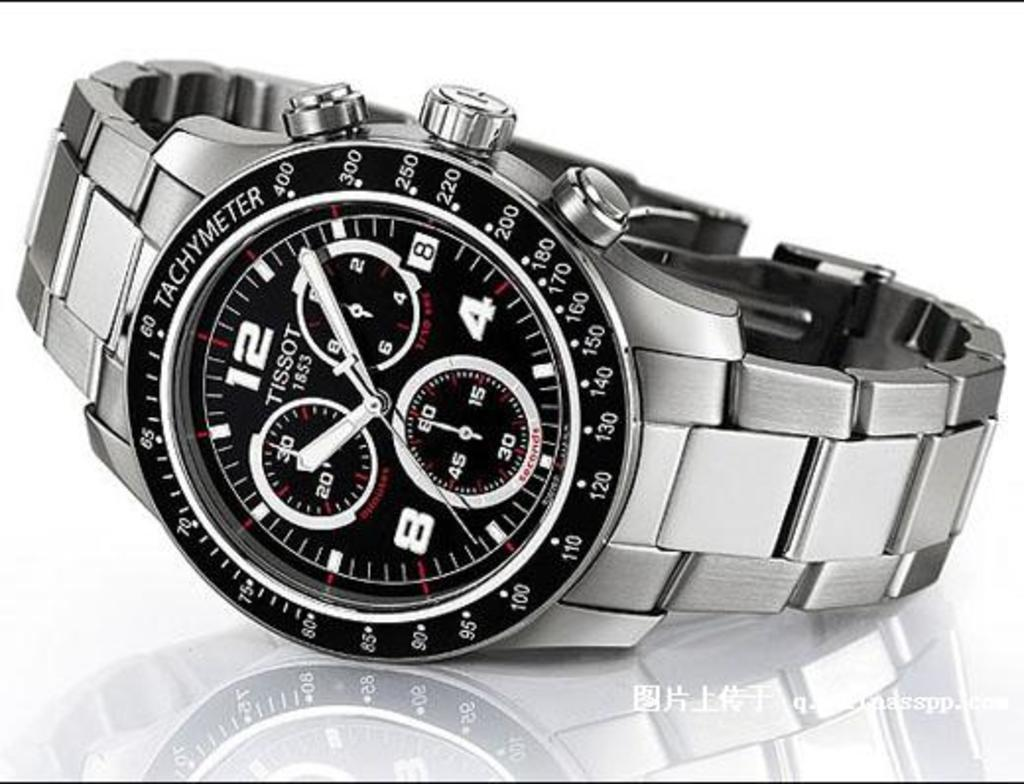<image>
Create a compact narrative representing the image presented. A Tissot brand watch has a silver band. 